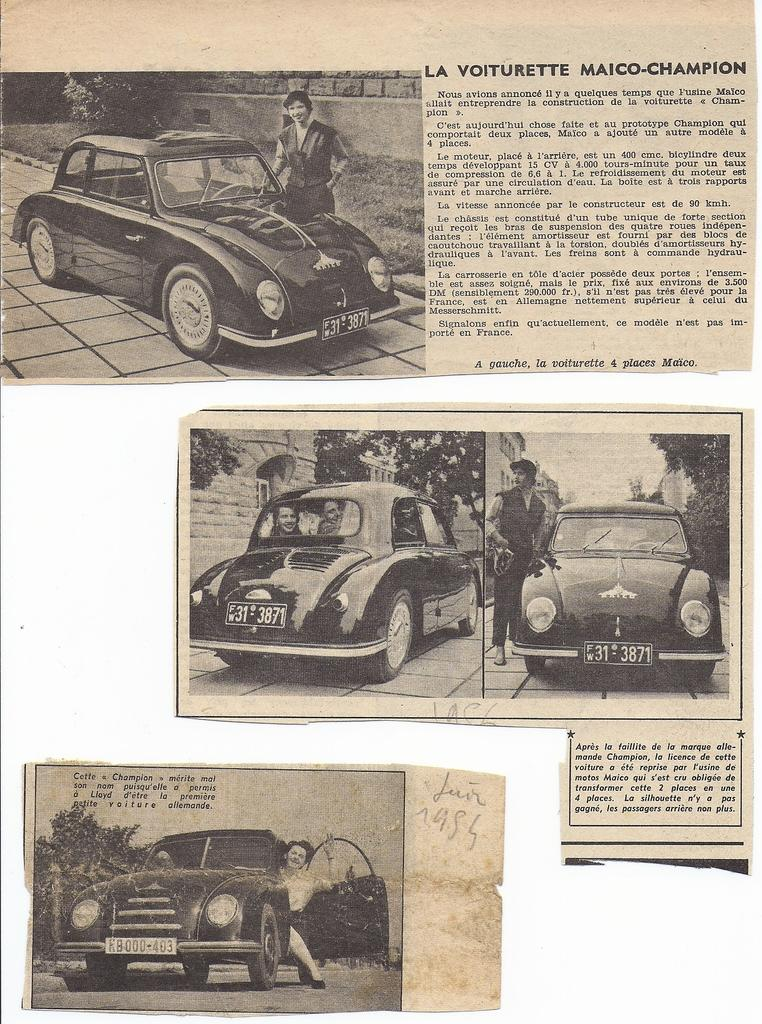What type of items are featured on the paper clippings in the image? The paper clippings contain images of cars. Are there any words or letters on the paper clippings? Yes, there is text on the paper clippings. How far away is the pail from the paper clippings in the image? There is no pail present in the image, so it cannot be determined how far away it might be from the paper clippings. 